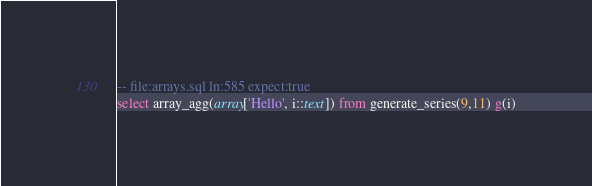<code> <loc_0><loc_0><loc_500><loc_500><_SQL_>-- file:arrays.sql ln:585 expect:true
select array_agg(array['Hello', i::text]) from generate_series(9,11) g(i)
</code> 